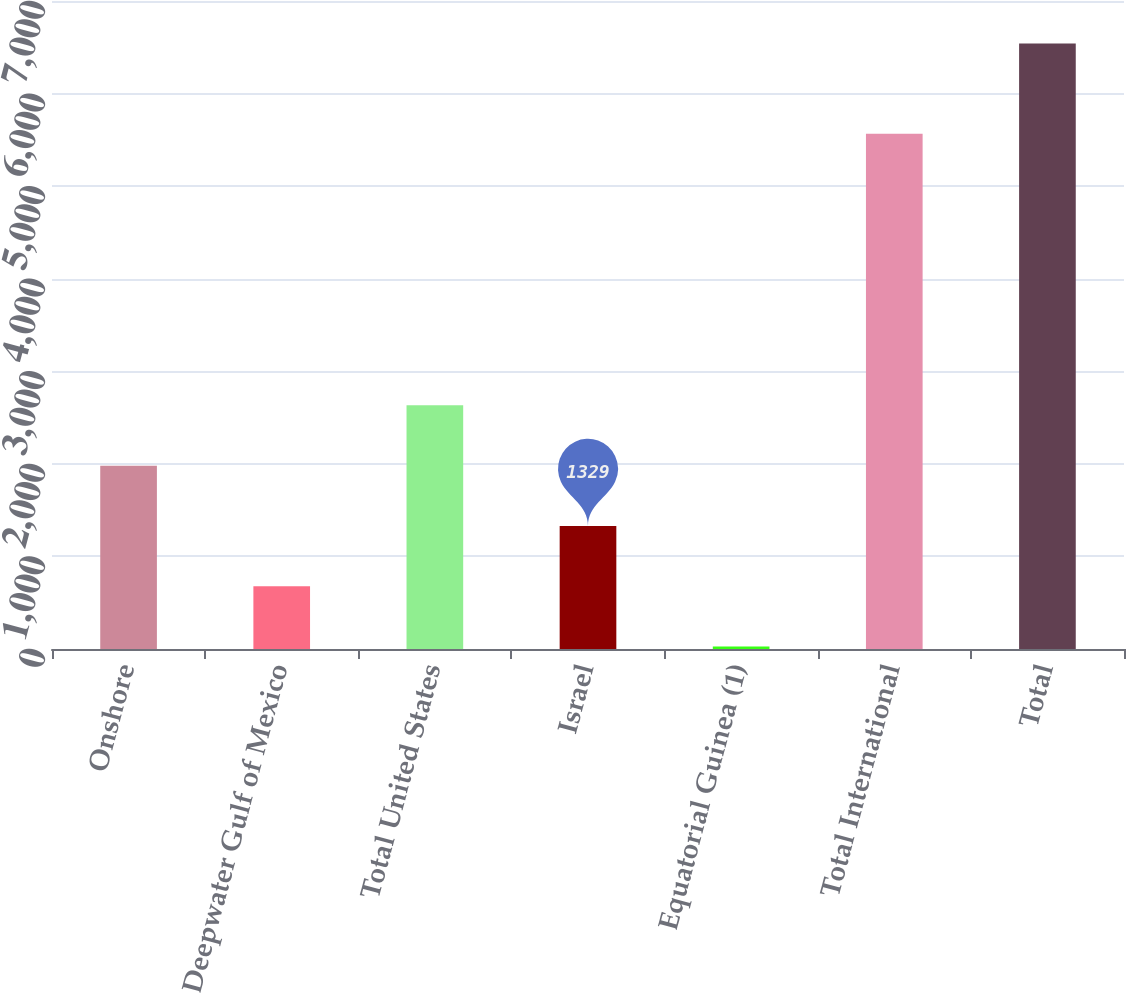Convert chart. <chart><loc_0><loc_0><loc_500><loc_500><bar_chart><fcel>Onshore<fcel>Deepwater Gulf of Mexico<fcel>Total United States<fcel>Israel<fcel>Equatorial Guinea (1)<fcel>Total International<fcel>Total<nl><fcel>1980.5<fcel>677.5<fcel>2632<fcel>1329<fcel>26<fcel>5565<fcel>6541<nl></chart> 